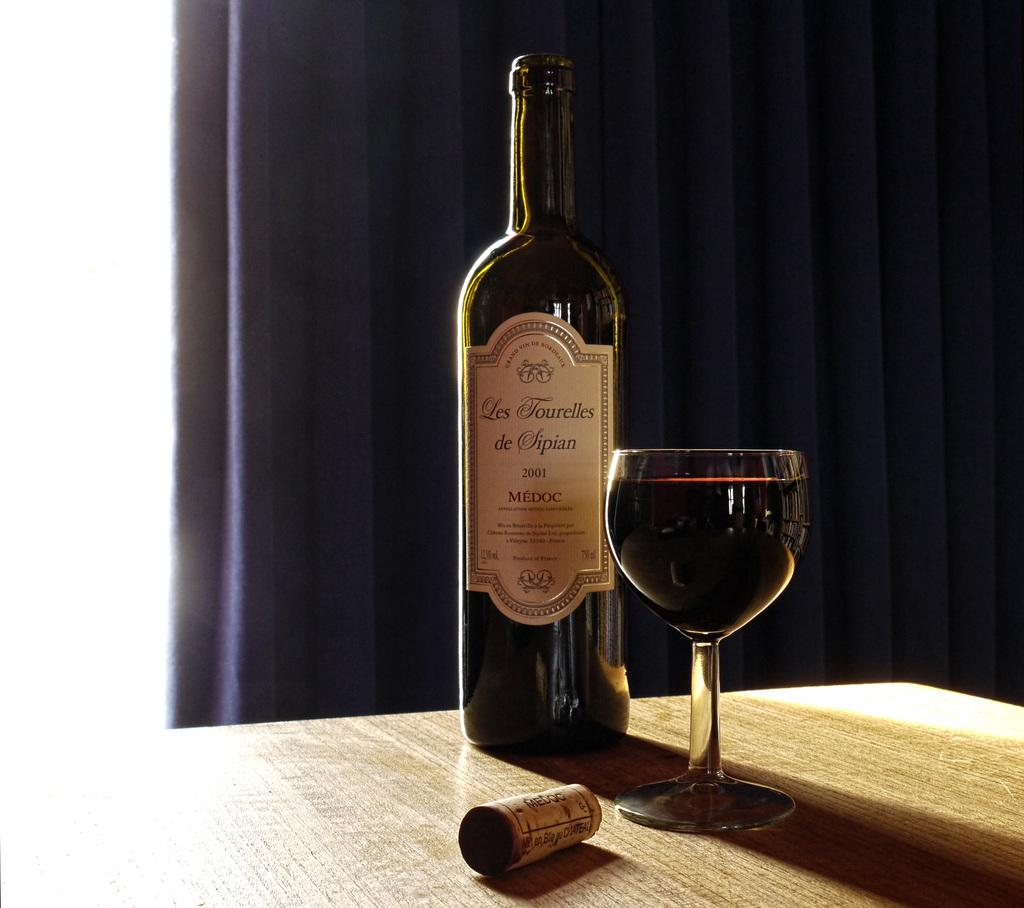<image>
Describe the image concisely. A full glass and a cork sit in front of a bottle Les Tourelles de Sipian MEDOC year 2001. 